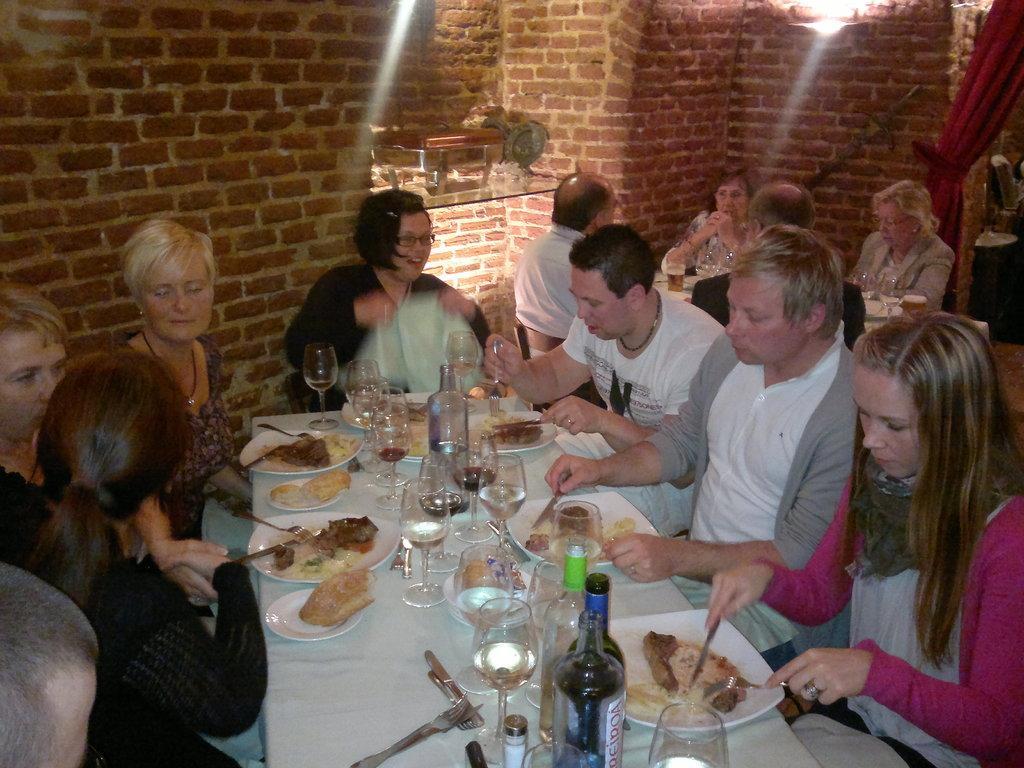In one or two sentences, can you explain what this image depicts? In the image we can see there are lot of people who are sitting on chair and on table there are wine glass and wine bottles and in plate there are food items. 